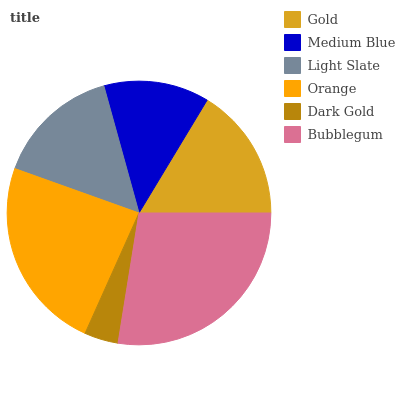Is Dark Gold the minimum?
Answer yes or no. Yes. Is Bubblegum the maximum?
Answer yes or no. Yes. Is Medium Blue the minimum?
Answer yes or no. No. Is Medium Blue the maximum?
Answer yes or no. No. Is Gold greater than Medium Blue?
Answer yes or no. Yes. Is Medium Blue less than Gold?
Answer yes or no. Yes. Is Medium Blue greater than Gold?
Answer yes or no. No. Is Gold less than Medium Blue?
Answer yes or no. No. Is Gold the high median?
Answer yes or no. Yes. Is Light Slate the low median?
Answer yes or no. Yes. Is Dark Gold the high median?
Answer yes or no. No. Is Dark Gold the low median?
Answer yes or no. No. 